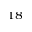<formula> <loc_0><loc_0><loc_500><loc_500>^ { 1 8 }</formula> 